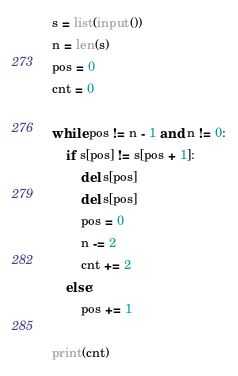Convert code to text. <code><loc_0><loc_0><loc_500><loc_500><_Python_>s = list(input())
n = len(s)
pos = 0
cnt = 0

while pos != n - 1 and n != 0:
    if s[pos] != s[pos + 1]:
        del s[pos]
        del s[pos]
        pos = 0
        n -= 2
        cnt += 2
    else:
        pos += 1

print(cnt)
</code> 